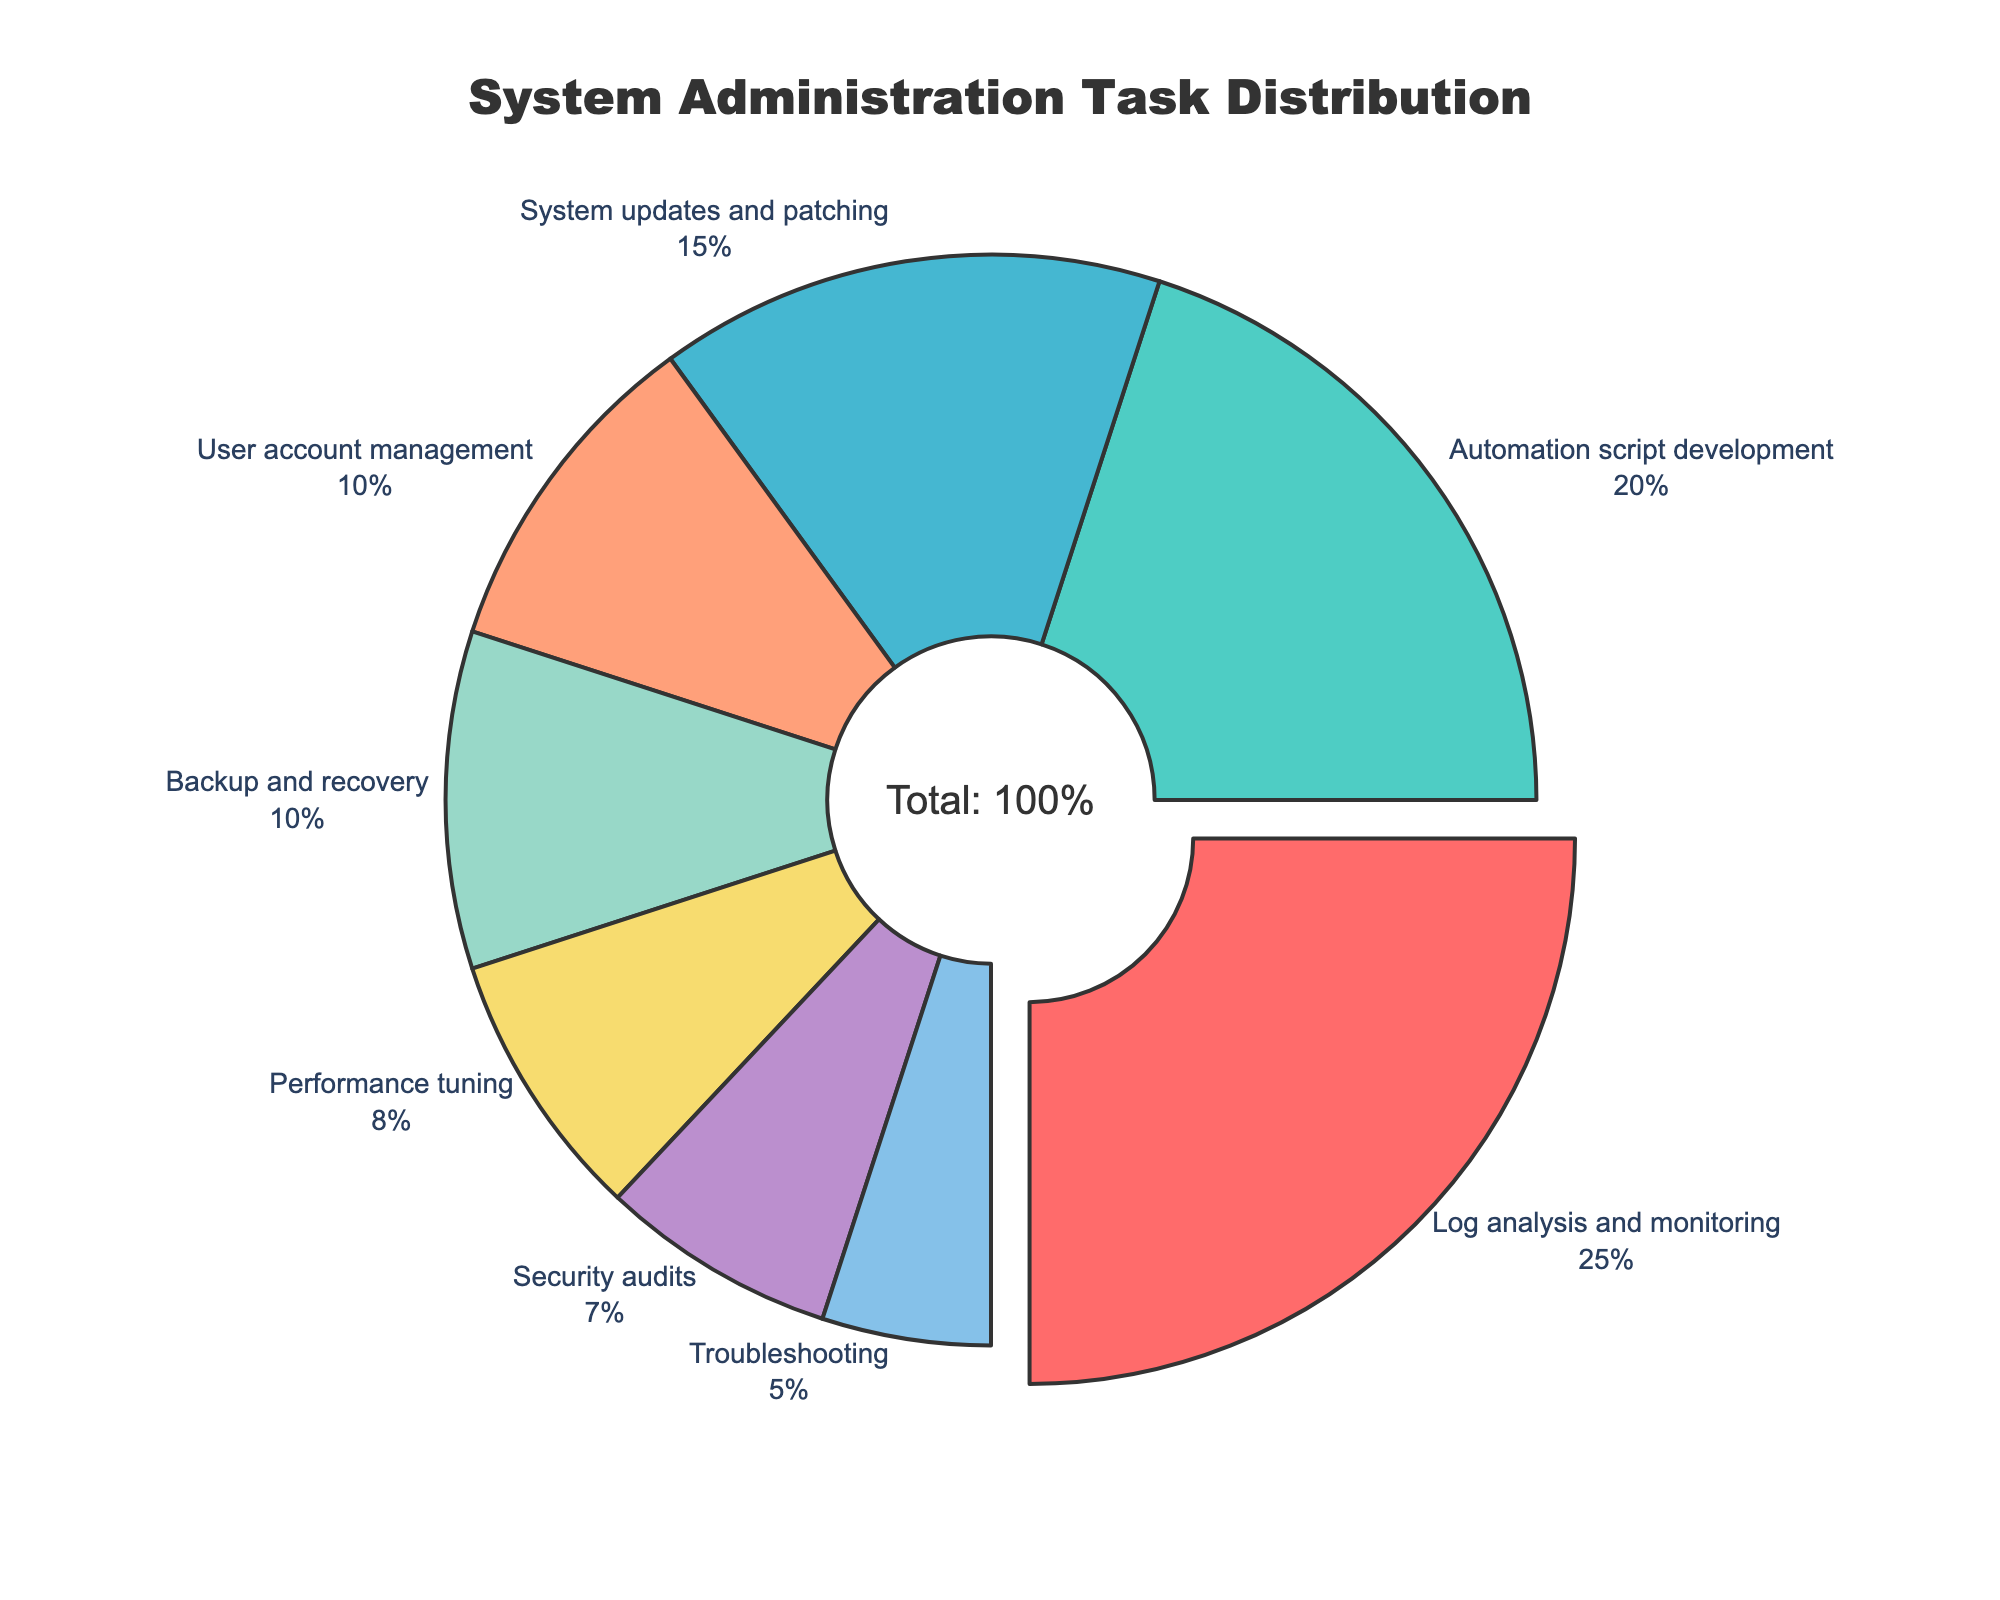What's the largest segment in the pie chart? The largest segment is the one representing the highest percentage of time spent on a task. Based on the data provided, "Log analysis and monitoring" is the largest segment with 25%.
Answer: Log analysis and monitoring What's the combined percentage of time spent on system updates and patching, and security audits? To find the combined percentage, add the percentages of "System updates and patching" (15%) and "Security audits" (7%). The sum is 15% + 7% = 22%.
Answer: 22% Which task takes up a smaller proportion of time, performance tuning or user account management? By comparing the percentages, "Performance tuning" takes up 8% while "User account management" takes up 10%. Therefore, "Performance tuning" takes up a smaller proportion of time.
Answer: Performance tuning Among the provided tasks, which ones take up the three smallest proportions of time? The three tasks with the smallest percentages are "Security audits" (7%), "Troubleshooting" (5%), and "Performance tuning" (8%).
Answer: Security audits, Troubleshooting, Performance tuning What's the combined percentage of time spent on automation script development and backup and recovery? To find the combined percentage, add the percentages of "Automation script development" (20%) and "Backup and recovery" (10%). The sum is 20% + 10% = 30%.
Answer: 30% Which segment is highlighted or pulled from the pie chart? The segment that is highlighted or pulled is usually the one with the highest percentage. Based on the data, "Log analysis and monitoring" is highlighted or pulled out.
Answer: Log analysis and monitoring How does the time spent on system updates and patching compare to the time spent on troubleshooting? By comparing the percentages, "System updates and patching" takes up 15% while "Troubleshooting" takes up 5%. Therefore, "System updates and patching" takes up more time.
Answer: System updates and patching What is the average proportion of time spent on backup, security audits, and troubleshooting? To find the average, add the percentages of "Backup and recovery" (10%), "Security audits" (7%), and "Troubleshooting" (5%), and then divide by 3. The sum is 10% + 7% + 5% = 22%, and the average is 22% / 3 ≈ 7.33%.
Answer: 7.33% Which task has a higher percentage, user account management or automation script development? By comparing the percentages, "Automation script development" takes up 20% while "User account management" takes up 10%. Therefore, "Automation script development" has a higher percentage.
Answer: Automation script development What is the total percentage of time spent on performance tuning, user account management, and security audits combined? To find the total percentage, add the percentages of "Performance tuning" (8%), "User account management" (10%), and "Security audits" (7%). The sum is 8% + 10% + 7% = 25%.
Answer: 25% 